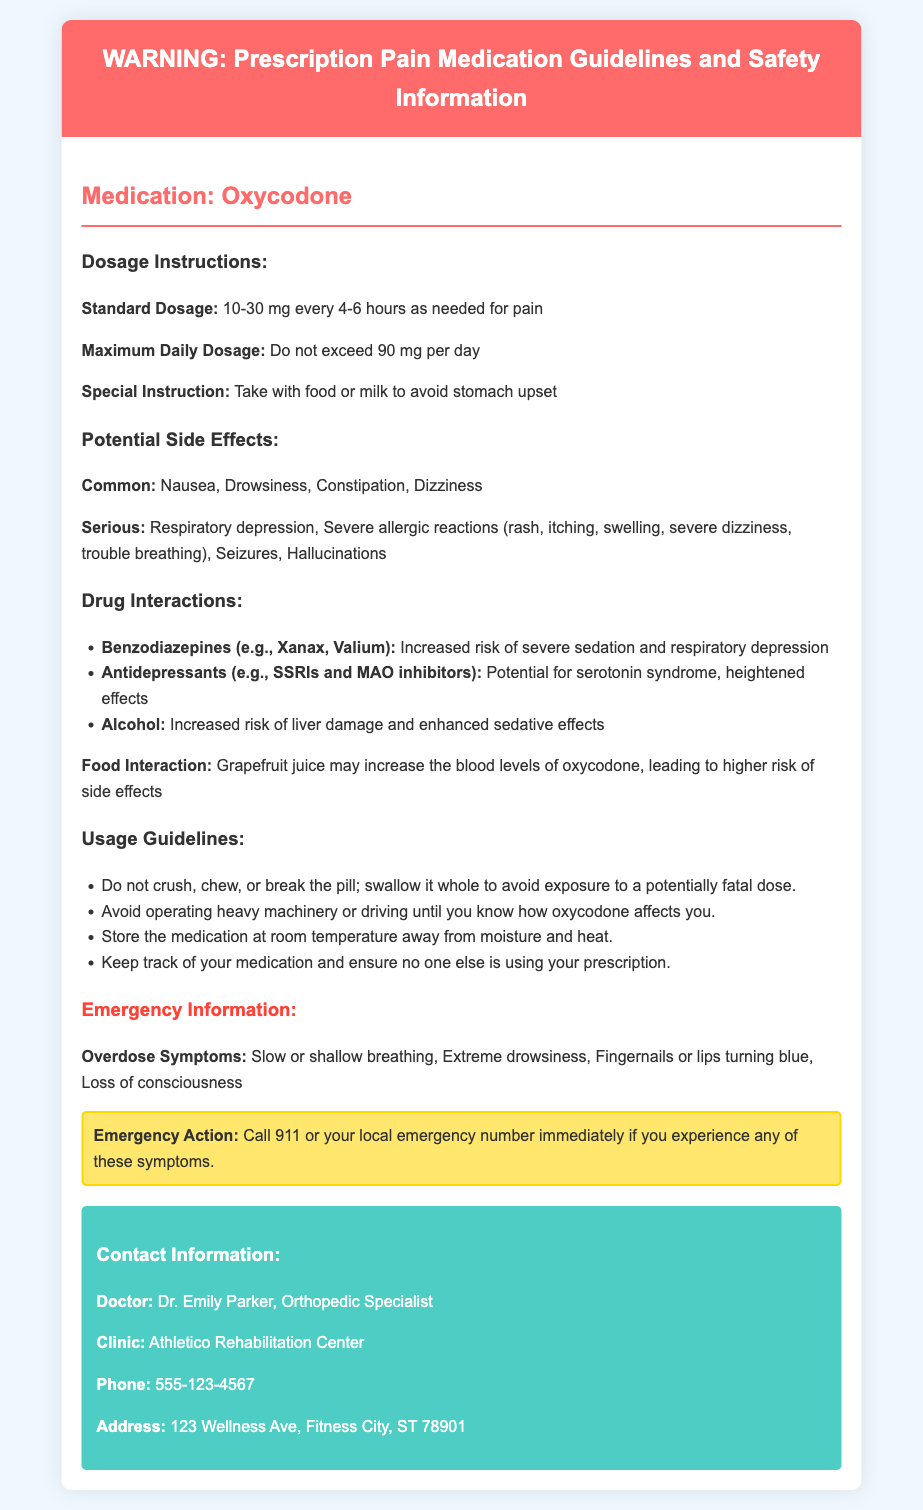What is the standard dosage of Oxycodone? The standard dosage for Oxycodone is provided in the document as 10-30 mg every 4-6 hours as needed for pain.
Answer: 10-30 mg every 4-6 hours What is the maximum daily dosage of Oxycodone? The document states that the maximum daily dosage of Oxycodone should not exceed 90 mg per day.
Answer: 90 mg Name a common side effect of Oxycodone. The document lists common side effects of Oxycodone, one of which is nausea.
Answer: Nausea What interactions does Oxycodone have with benzodiazepines? According to the document, Oxycodone and benzodiazepines can lead to increased risk of severe sedation and respiratory depression.
Answer: Increased risk of severe sedation and respiratory depression What should you do if you experience overdose symptoms? The document advises calling 911 or your local emergency number immediately if you experience overdose symptoms like slow or shallow breathing.
Answer: Call 911 If a patient is taking Oxycodone, which food should they avoid? The document indicates that grapefruit juice should be avoided as it may increase the blood levels of oxycodone, leading to a higher risk of side effects.
Answer: Grapefruit juice What is the contact number for Dr. Emily Parker? The document lists the contact number for Dr. Emily Parker as 555-123-4567.
Answer: 555-123-4567 What guideline is mentioned regarding pill consumption? The document specifies that the pill should not be crushed, chewed, or broken, but swallowed whole.
Answer: Swallow it whole What is a serious side effect of Oxycodone? The document mentions that respiratory depression is a serious side effect of Oxycodone.
Answer: Respiratory depression 